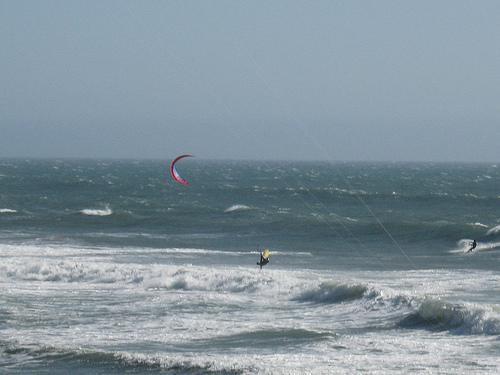How many people can you see in this picture?
Give a very brief answer. 2. 